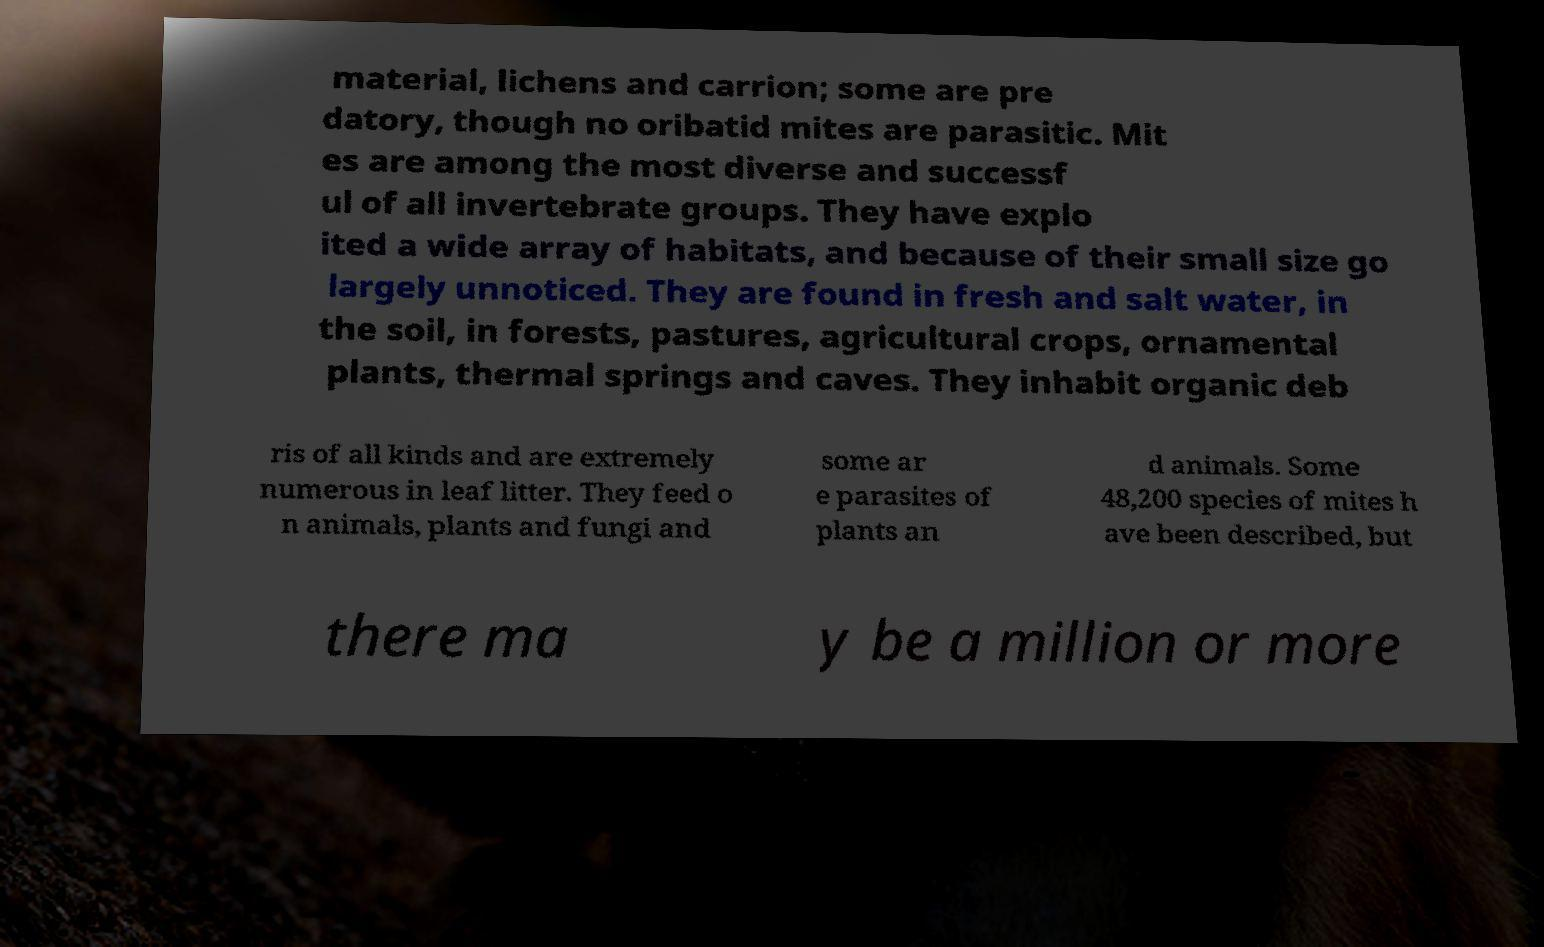Can you read and provide the text displayed in the image?This photo seems to have some interesting text. Can you extract and type it out for me? material, lichens and carrion; some are pre datory, though no oribatid mites are parasitic. Mit es are among the most diverse and successf ul of all invertebrate groups. They have explo ited a wide array of habitats, and because of their small size go largely unnoticed. They are found in fresh and salt water, in the soil, in forests, pastures, agricultural crops, ornamental plants, thermal springs and caves. They inhabit organic deb ris of all kinds and are extremely numerous in leaf litter. They feed o n animals, plants and fungi and some ar e parasites of plants an d animals. Some 48,200 species of mites h ave been described, but there ma y be a million or more 